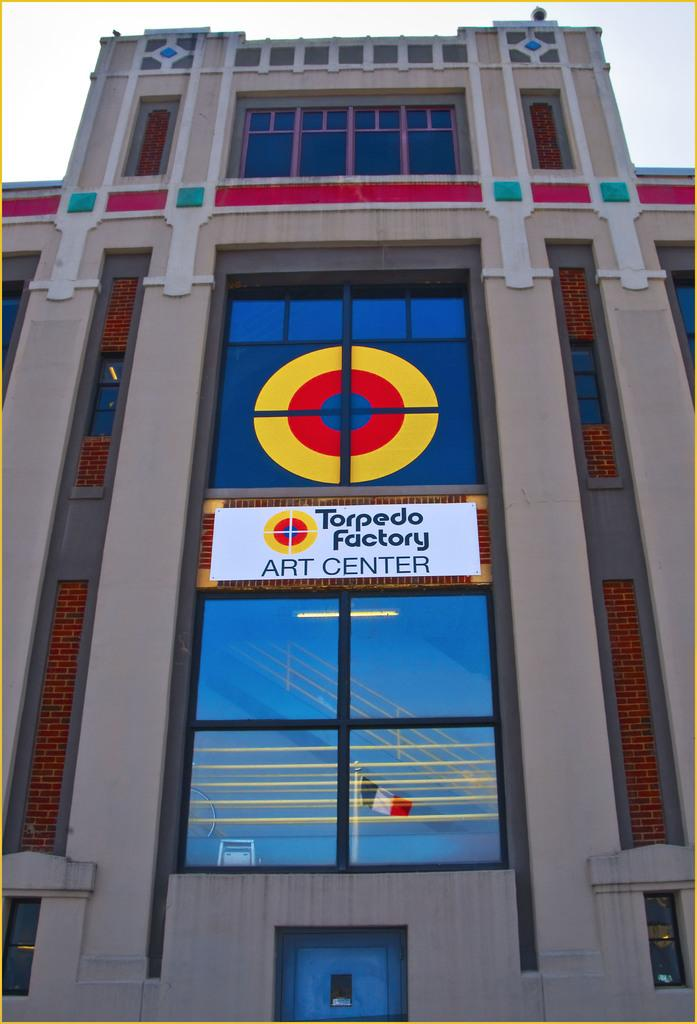What type of structure is visible in the picture? There is a building in the picture. What feature can be seen in the center of the picture? There is a glass window in the center of the picture. What is written or displayed on the glass window? There is text on the glass window. How can one enter the building? There is a door at the bottom of the picture. Are there any pets visible on the island in the picture? There is no island or pets present in the picture; it features a building with a glass window, text, and a door. 